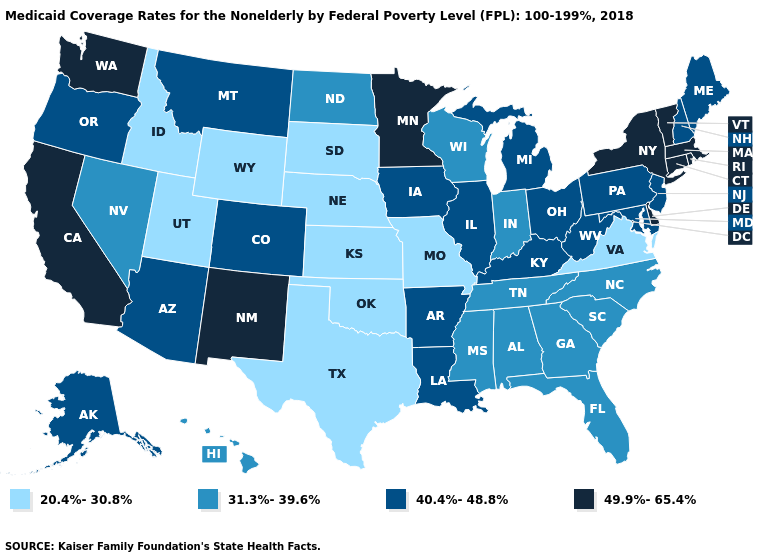Does Illinois have a lower value than Rhode Island?
Short answer required. Yes. Does Alabama have the lowest value in the USA?
Answer briefly. No. What is the value of Massachusetts?
Answer briefly. 49.9%-65.4%. What is the value of Colorado?
Answer briefly. 40.4%-48.8%. What is the value of California?
Give a very brief answer. 49.9%-65.4%. Name the states that have a value in the range 20.4%-30.8%?
Be succinct. Idaho, Kansas, Missouri, Nebraska, Oklahoma, South Dakota, Texas, Utah, Virginia, Wyoming. Name the states that have a value in the range 40.4%-48.8%?
Give a very brief answer. Alaska, Arizona, Arkansas, Colorado, Illinois, Iowa, Kentucky, Louisiana, Maine, Maryland, Michigan, Montana, New Hampshire, New Jersey, Ohio, Oregon, Pennsylvania, West Virginia. Name the states that have a value in the range 40.4%-48.8%?
Keep it brief. Alaska, Arizona, Arkansas, Colorado, Illinois, Iowa, Kentucky, Louisiana, Maine, Maryland, Michigan, Montana, New Hampshire, New Jersey, Ohio, Oregon, Pennsylvania, West Virginia. Does Kentucky have a higher value than Oklahoma?
Concise answer only. Yes. Does Montana have a higher value than Connecticut?
Quick response, please. No. What is the highest value in states that border Maryland?
Be succinct. 49.9%-65.4%. What is the lowest value in the South?
Short answer required. 20.4%-30.8%. Does Vermont have the highest value in the USA?
Answer briefly. Yes. What is the value of Montana?
Concise answer only. 40.4%-48.8%. Name the states that have a value in the range 49.9%-65.4%?
Concise answer only. California, Connecticut, Delaware, Massachusetts, Minnesota, New Mexico, New York, Rhode Island, Vermont, Washington. 